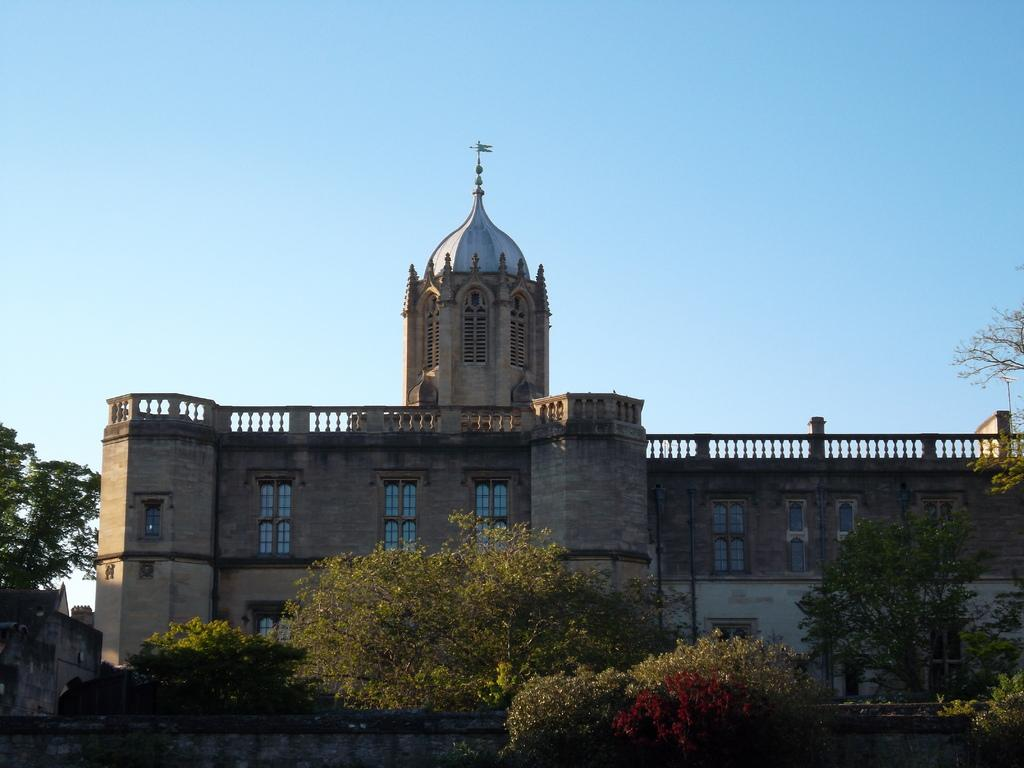What type of structures can be seen in the image? There are buildings in the image. What other natural elements are present in the image? There are trees in the image. What is visible at the top of the image? The sky is visible at the top of the image. Where is the library located in the image? There is no library mentioned or visible in the image. What type of fiction can be found in the trees in the image? There is no fiction present in the image, as it only features buildings, trees, and the sky. 